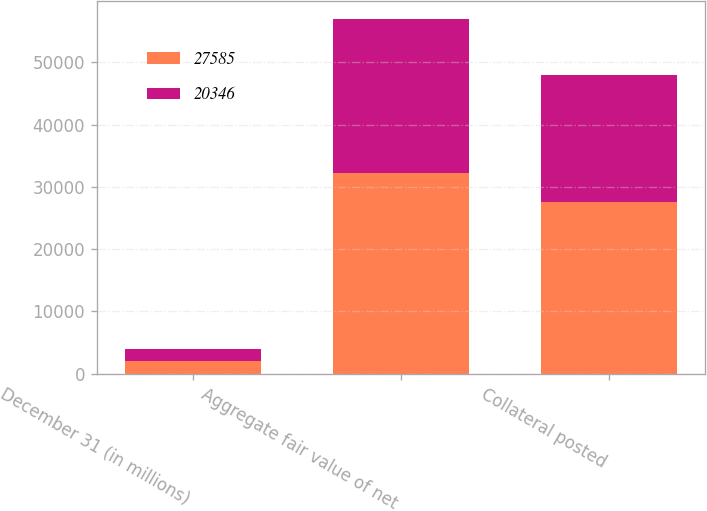<chart> <loc_0><loc_0><loc_500><loc_500><stacked_bar_chart><ecel><fcel>December 31 (in millions)<fcel>Aggregate fair value of net<fcel>Collateral posted<nl><fcel>27585<fcel>2014<fcel>32303<fcel>27585<nl><fcel>20346<fcel>2013<fcel>24631<fcel>20346<nl></chart> 